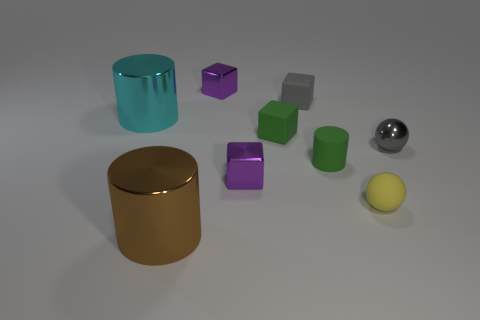Subtract all green rubber cylinders. How many cylinders are left? 2 Subtract all green cylinders. How many purple blocks are left? 2 Subtract all gray cubes. How many cubes are left? 3 Add 1 purple objects. How many objects exist? 10 Subtract 1 blocks. How many blocks are left? 3 Subtract all blocks. How many objects are left? 5 Subtract all red cubes. Subtract all green cylinders. How many cubes are left? 4 Subtract all big metal things. Subtract all shiny cylinders. How many objects are left? 5 Add 3 cyan shiny cylinders. How many cyan shiny cylinders are left? 4 Add 5 metal cylinders. How many metal cylinders exist? 7 